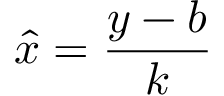<formula> <loc_0><loc_0><loc_500><loc_500>\hat { x } = \frac { y - b } { k }</formula> 